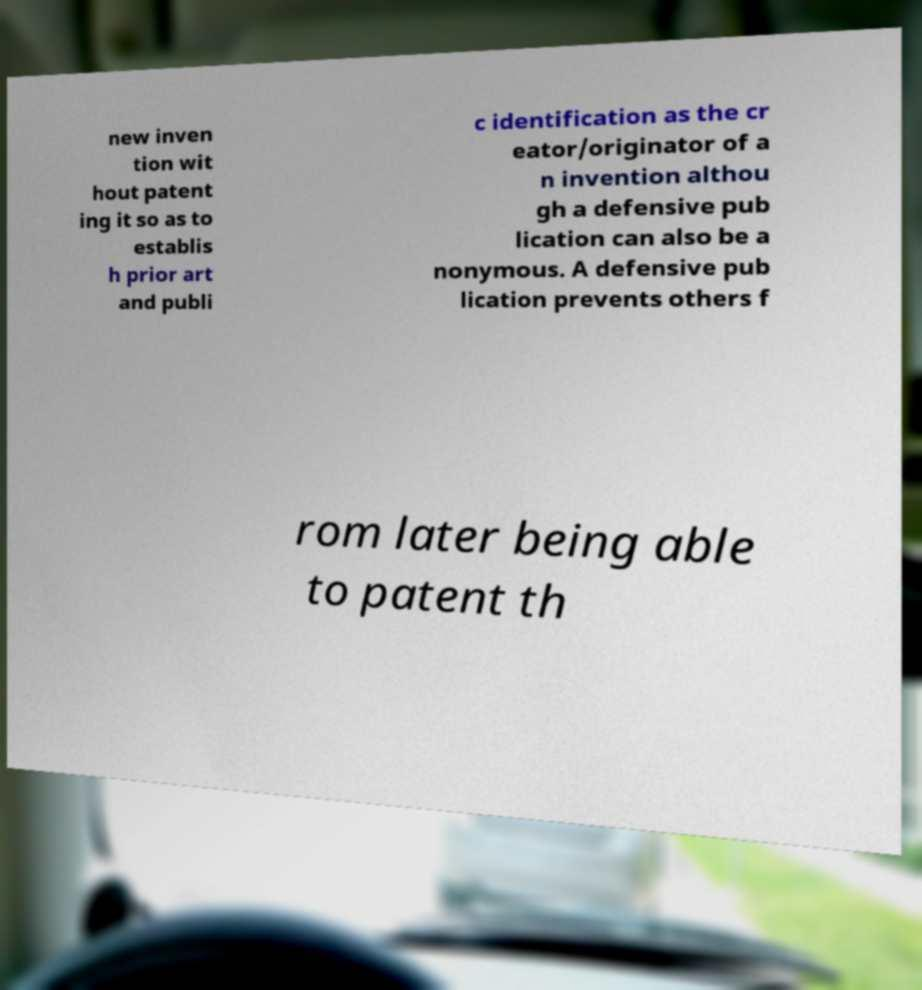I need the written content from this picture converted into text. Can you do that? new inven tion wit hout patent ing it so as to establis h prior art and publi c identification as the cr eator/originator of a n invention althou gh a defensive pub lication can also be a nonymous. A defensive pub lication prevents others f rom later being able to patent th 